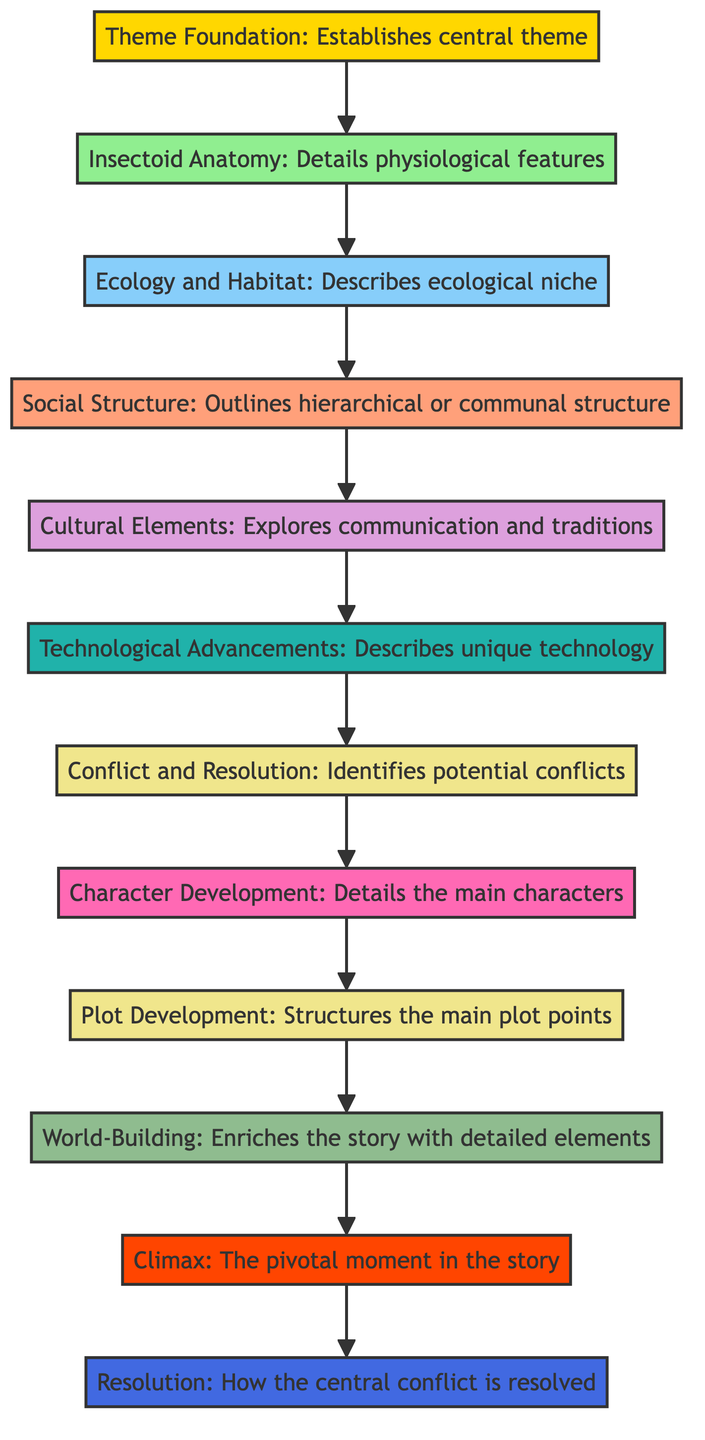What is the last element in the flowchart? The last element in the flowchart is "Resolution," which addresses how the central conflict is resolved and the aftermath for the insectoid civilization.
Answer: Resolution Which element comes after "Cultural Elements"? "Technological Advancements" comes after "Cultural Elements" in the flowchart, indicating that the cultural aspects lead into the unique technology aspects of the civilization.
Answer: Technological Advancements How many total elements are in the flowchart? There are 12 elements in total, starting from "Theme Foundation" at the bottom and moving up to "Resolution" at the top, including all thematic and narrative components.
Answer: 12 What is the focus of the "Character Development" element? The focus of "Character Development" is on detailing the main characters and their roles, emphasizing their individual traits and development arcs throughout the story.
Answer: Main characters Which element precedes the "Climax"? The "World-Building" element precedes the "Climax," indicating that establishing the setting enriches the story leading up to the pivotal moment.
Answer: World-Building What type of element is "Technological Advancements"? "Technological Advancements" is classified as a technological element, detailing the unique technology that combines organic and mechanical aspects within the insectoid civilization.
Answer: Technological element How does "Insectoid Anatomy" connect to "Ecology and Habitat"? "Insectoid Anatomy" directly flows into "Ecology and Habitat," suggesting that understanding the physiological features of the insectoids is essential for describing their ecological niche.
Answer: Directly flows What does "Plot Development" encompass? "Plot Development" encompasses structuring the main plot points, including the beginning, major turning points, and conclusion of the story, establishing a coherent narrative arc.
Answer: Main plot points 